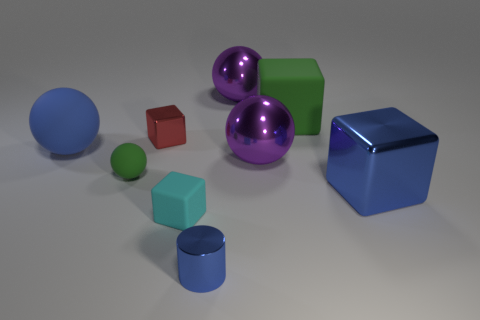Is there anything else that is the same shape as the tiny blue thing?
Your response must be concise. No. Are there an equal number of purple things that are left of the tiny cyan cube and tiny cylinders?
Make the answer very short. No. There is a small cylinder that is the same color as the big metallic block; what is it made of?
Your response must be concise. Metal. There is a blue metallic cylinder; is its size the same as the purple metallic object in front of the large blue ball?
Give a very brief answer. No. How many other things are the same size as the blue metal cube?
Keep it short and to the point. 4. What number of other objects are there of the same color as the big rubber sphere?
Provide a succinct answer. 2. Is there any other thing that has the same size as the green rubber cube?
Offer a terse response. Yes. What number of other objects are the same shape as the tiny cyan rubber thing?
Your response must be concise. 3. Does the blue cube have the same size as the blue matte ball?
Offer a very short reply. Yes. Are any small blue metal cubes visible?
Offer a terse response. No. 